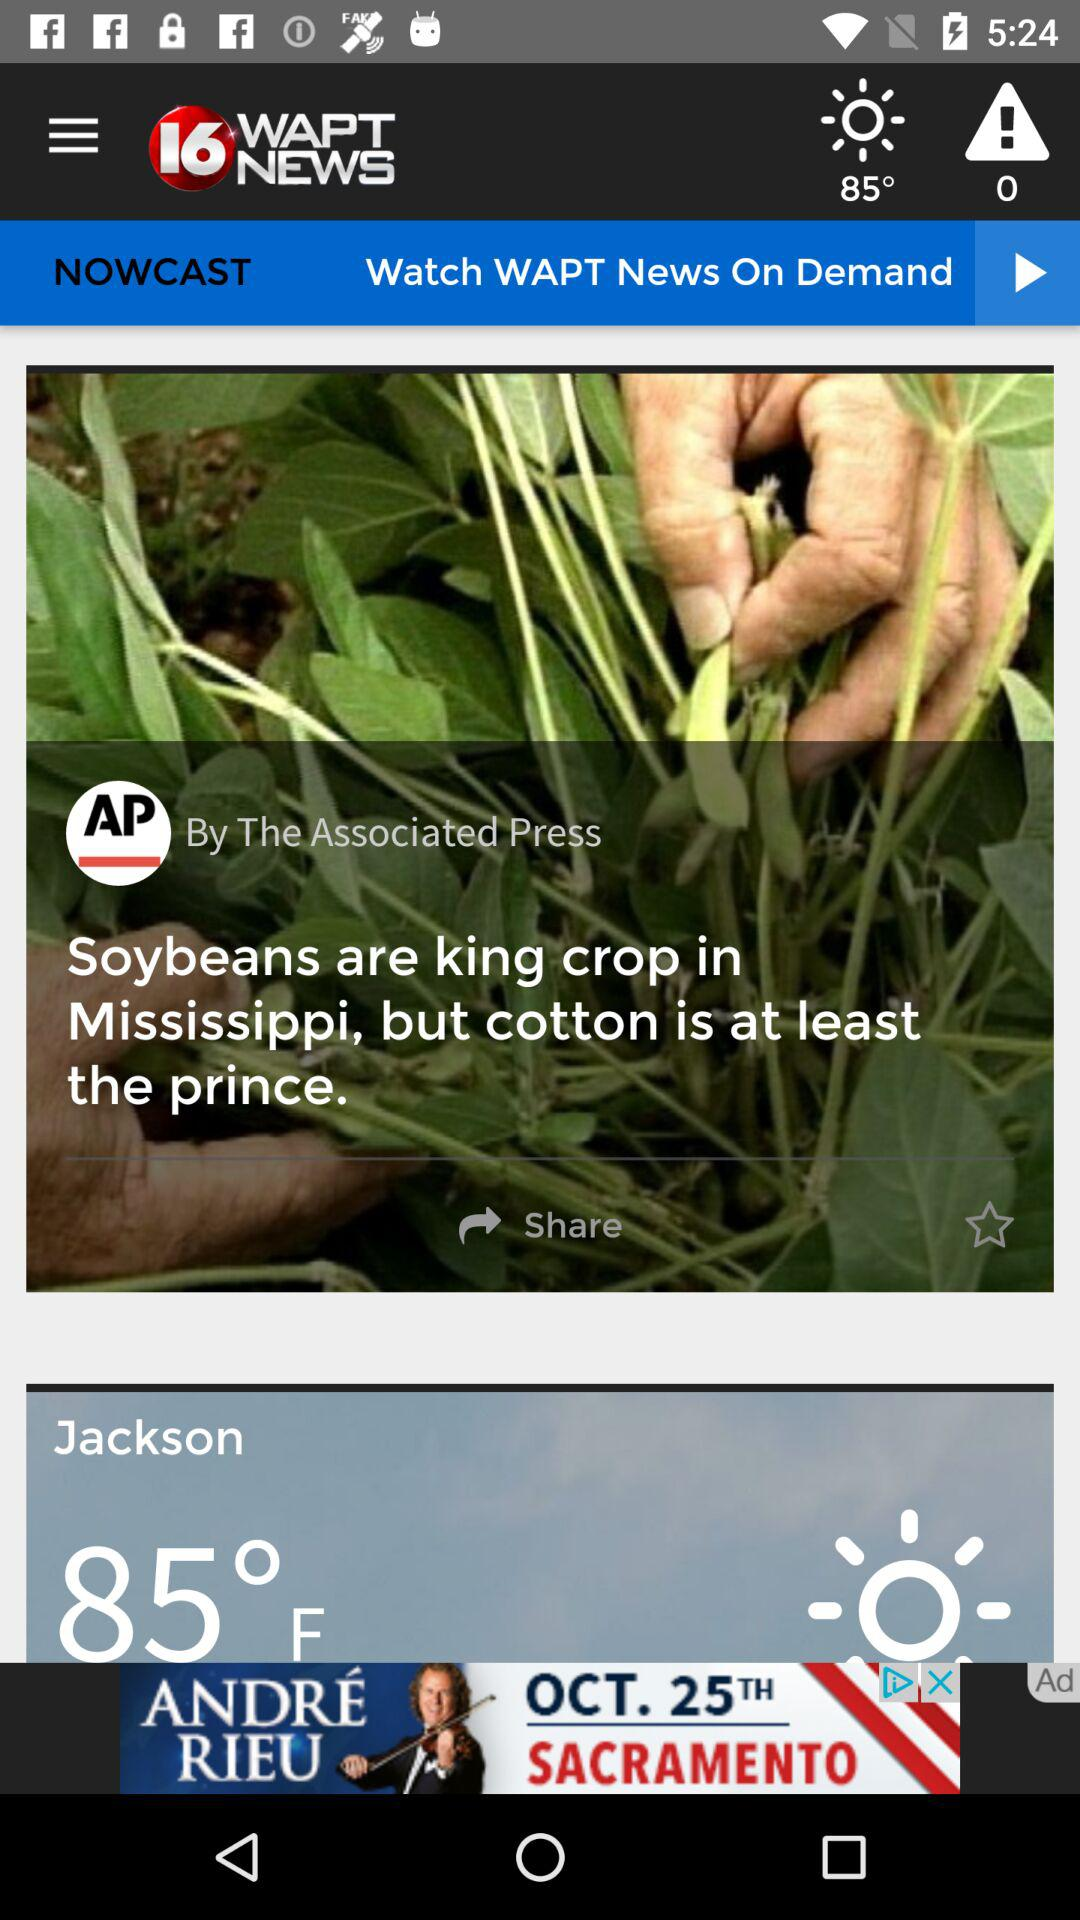Who published the news "Soybeans are king crop in Mississippi, but cotton is at least the prince"? The news was published by "Associated Press". 